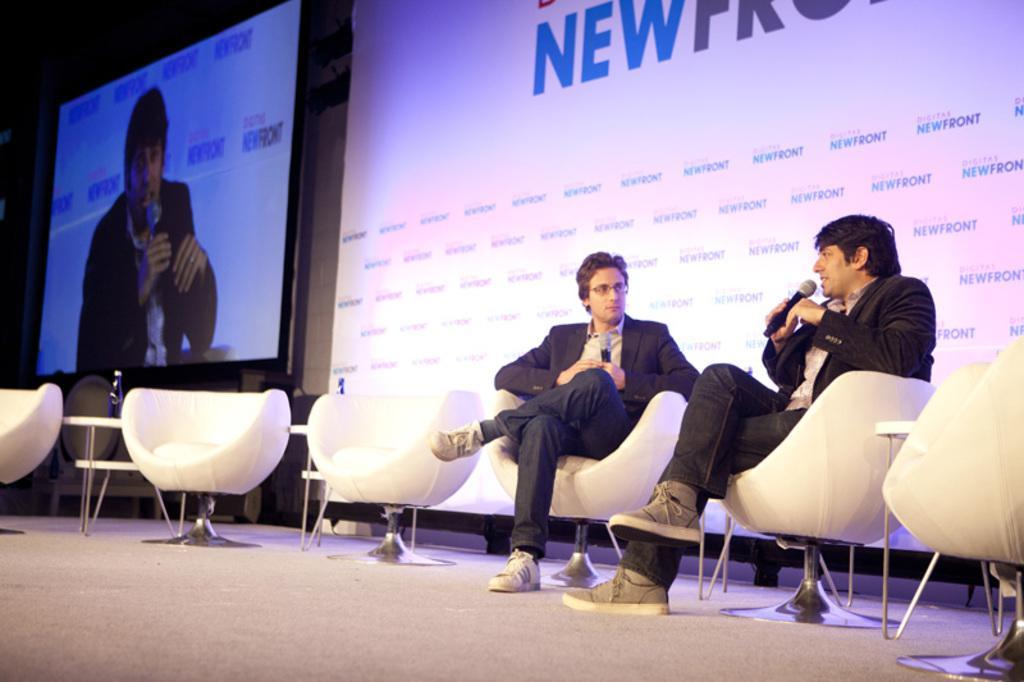Describe this image in one or two sentences. As we can see in the image there is a screen, banner, two people sitting on chairs and these two people are holding mics. 